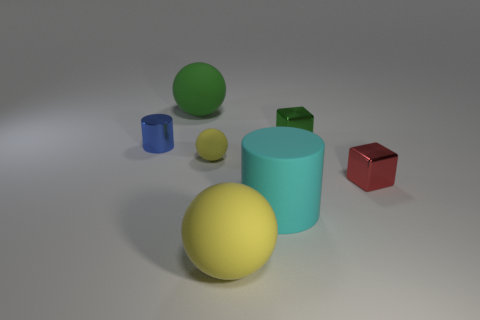What shape is the big thing that is the same color as the tiny ball?
Keep it short and to the point. Sphere. What size is the matte ball that is the same color as the tiny matte object?
Offer a terse response. Large. There is a tiny matte object; does it have the same color as the big matte ball that is on the right side of the big green object?
Offer a very short reply. Yes. Are there any yellow rubber things of the same size as the blue cylinder?
Make the answer very short. Yes. Does the large rubber object behind the tiny metal cylinder have the same shape as the large yellow thing?
Ensure brevity in your answer.  Yes. There is a tiny cube to the left of the tiny red block; what is its material?
Your answer should be very brief. Metal. There is a object right of the green thing on the right side of the tiny yellow object; what is its shape?
Your response must be concise. Cube. Does the small red thing have the same shape as the green object on the right side of the tiny yellow rubber object?
Offer a terse response. Yes. There is a big rubber sphere that is in front of the small green block; what number of big green matte objects are to the right of it?
Offer a terse response. 0. There is a small red thing that is the same shape as the green metal object; what material is it?
Your answer should be very brief. Metal. 